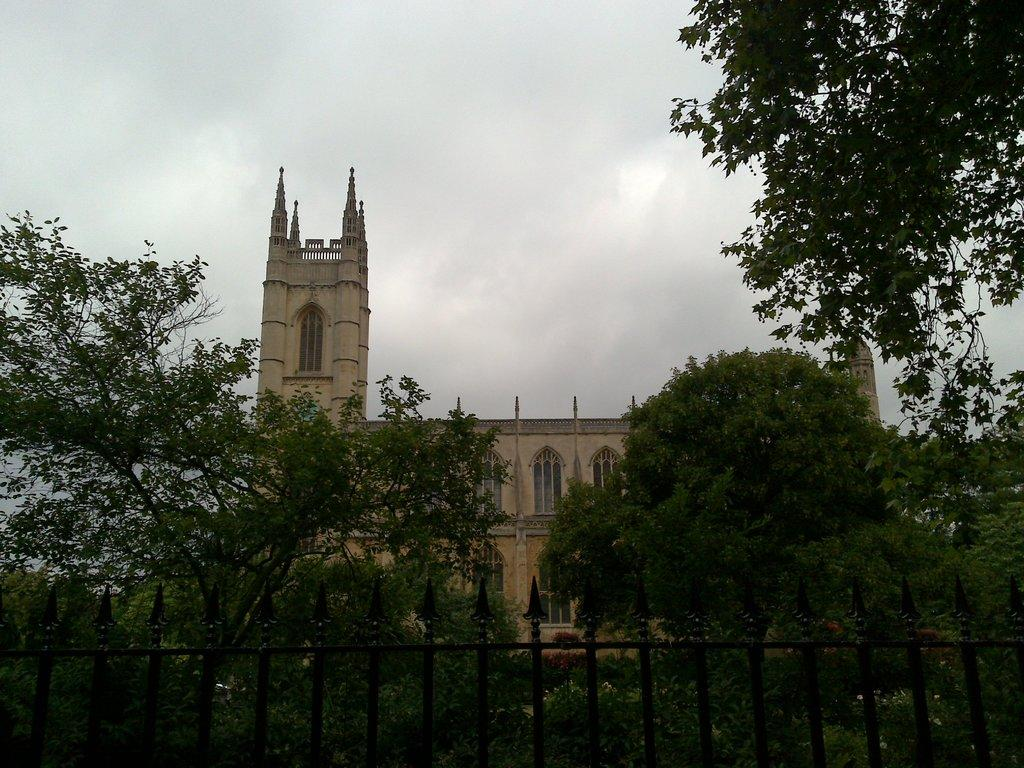What type of vegetation can be seen in the image? There are trees in the image. What type of fencing is present in the image? There is black fencing in the image. What type of structure is visible in the image? There is a building in the image. What is the color of the building? The building is in cream color. What architectural feature can be seen in the image? There are windows in the image. What is the color of the sky in the image? The sky is in white color. How many ants can be seen climbing the tree in the image? There are no ants present in the image. What type of system is being used to power the building in the image? There is no information about a power system in the image; it only shows a building, trees, fencing, and the sky. 